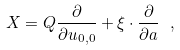Convert formula to latex. <formula><loc_0><loc_0><loc_500><loc_500>X = Q \frac { \partial } { \partial u _ { 0 , 0 } } + \xi \cdot \frac { \partial } { \partial { a } } \ ,</formula> 